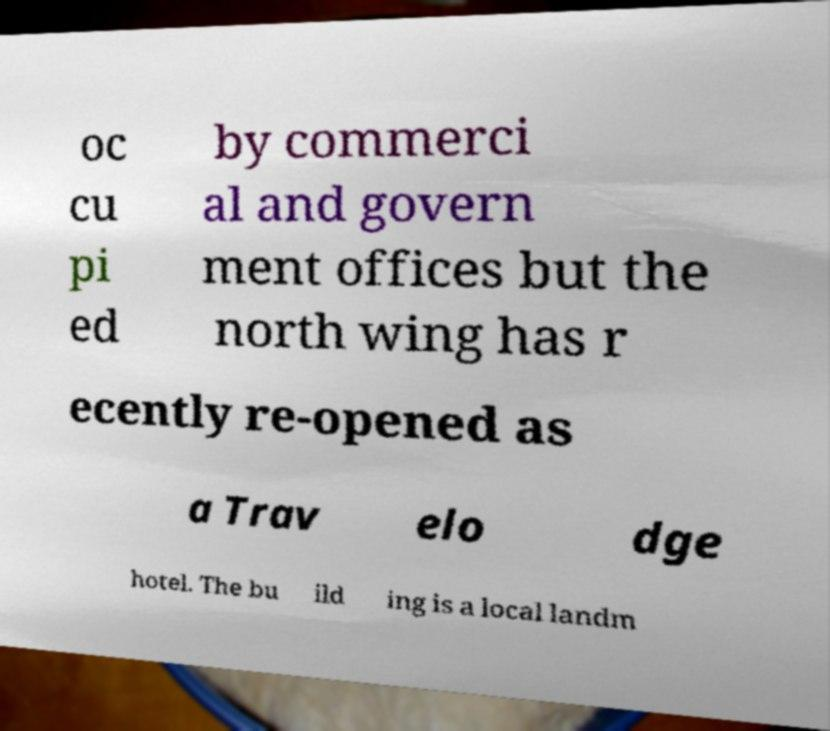Could you extract and type out the text from this image? oc cu pi ed by commerci al and govern ment offices but the north wing has r ecently re-opened as a Trav elo dge hotel. The bu ild ing is a local landm 